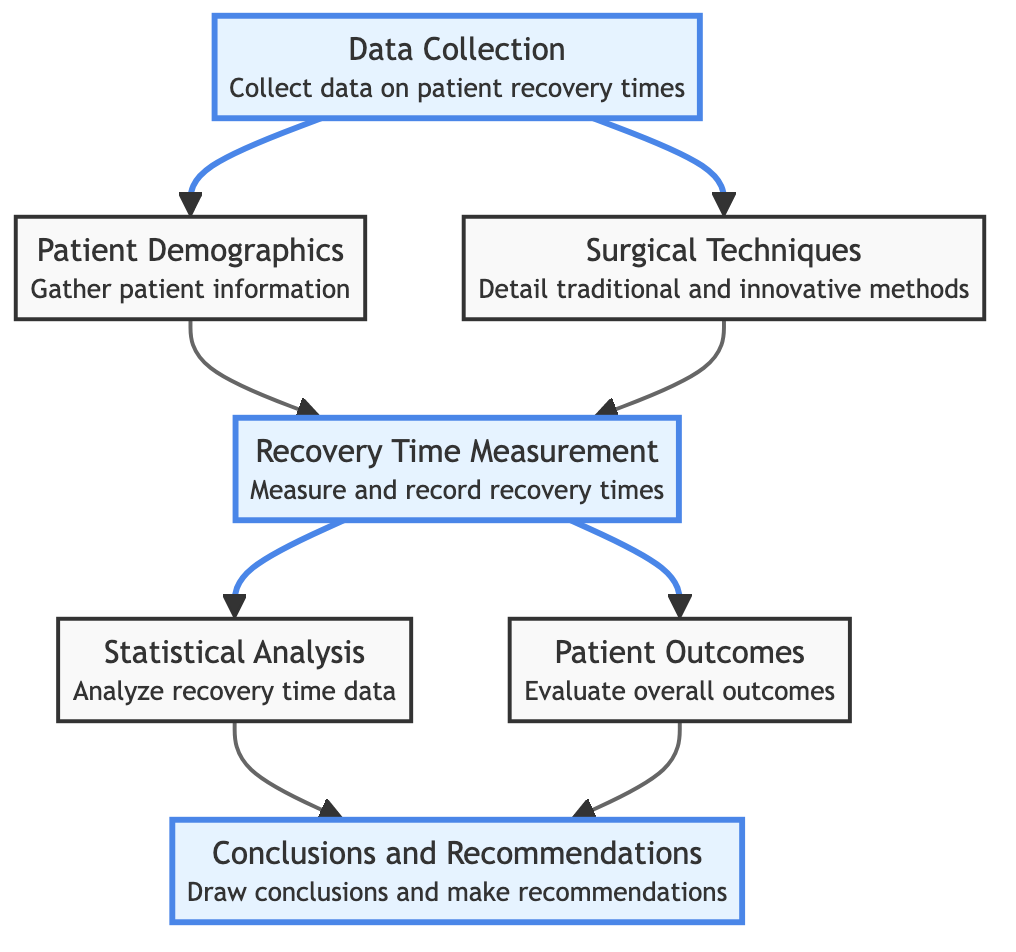What is the title of the block diagram? The title of the block diagram is explicitly stated in the diagram at the top and it is "Comparative Study of Patient Recovery Times: Traditional vs. Innovative Surgical Methods."
Answer: Comparative Study of Patient Recovery Times: Traditional vs. Innovative Surgical Methods How many blocks are there in the diagram? By counting the blocks represented in the diagram, we find a total of seven distinct blocks.
Answer: 7 Which block describes the gathering of patient information? The block that describes gathering patient information is labeled "Patient Demographics," as indicated in the diagram's labeling and description.
Answer: Patient Demographics What connects the "Data Collection" block to the next two blocks? The "Data Collection" block is connected to both the "Patient Demographics" and "Surgical Techniques" blocks, as shown by the arrows leading from it.
Answer: Patient Demographics and Surgical Techniques What type of analysis is performed after measuring recovery times? After measuring recovery times in the "Recovery Time Measurement" block, the next step specified is "Statistical Analysis," indicating that statistical methods will be used for further evaluation.
Answer: Statistical Analysis Which two aspects are evaluated after recording recovery times? The two aspects evaluated after recording recovery times in the "Recovery Time Measurement" block are "Statistical Analysis" and "Patient Outcomes," both connected by arrows from the recovery measurement block.
Answer: Statistical Analysis and Patient Outcomes What is the final output of the process? The final output of the process is represented in the last block, which is labeled "Conclusions and Recommendations," where insights derived from the study are presented.
Answer: Conclusions and Recommendations Which block directly follows "Recovery Time Measurement" in the diagram? The block that directly follows "Recovery Time Measurement" is split into two paths leading to "Statistical Analysis" and "Patient Outcomes," both of which are subsequent steps in the process flow.
Answer: Statistical Analysis and Patient Outcomes What is the primary function of the "Surgical Techniques" block? The primary function of the "Surgical Techniques" block is to detail the traditional and innovative surgical methods employed in the study, as described in its definition within the diagram.
Answer: Detail traditional and innovative surgical methods 